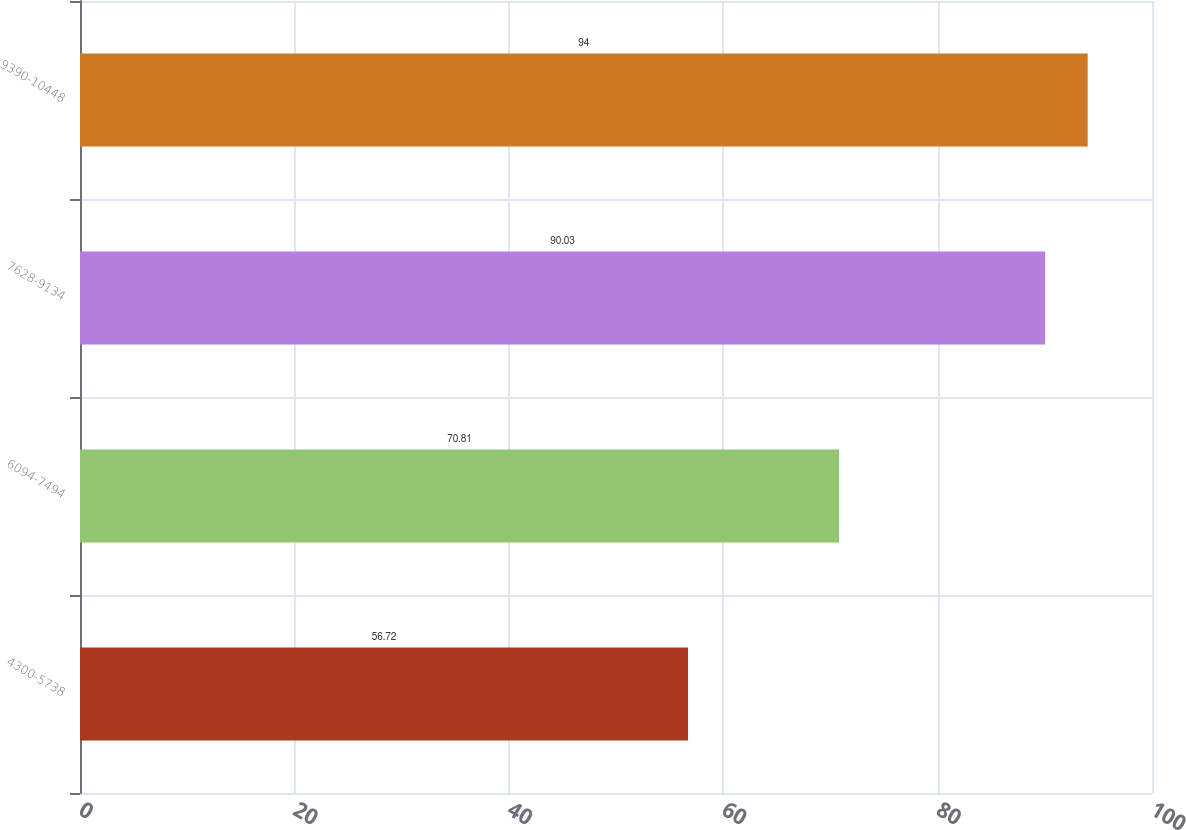Convert chart. <chart><loc_0><loc_0><loc_500><loc_500><bar_chart><fcel>4300-5738<fcel>6094-7494<fcel>7628-9134<fcel>9390-10448<nl><fcel>56.72<fcel>70.81<fcel>90.03<fcel>94<nl></chart> 